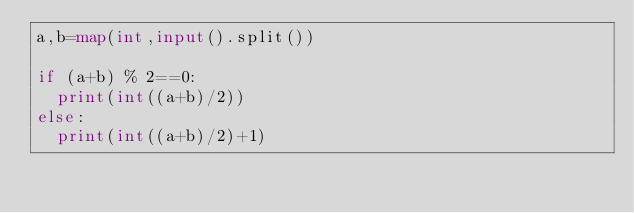Convert code to text. <code><loc_0><loc_0><loc_500><loc_500><_Python_>a,b=map(int,input().split())

if (a+b) % 2==0:
  print(int((a+b)/2))
else:
  print(int((a+b)/2)+1)
</code> 